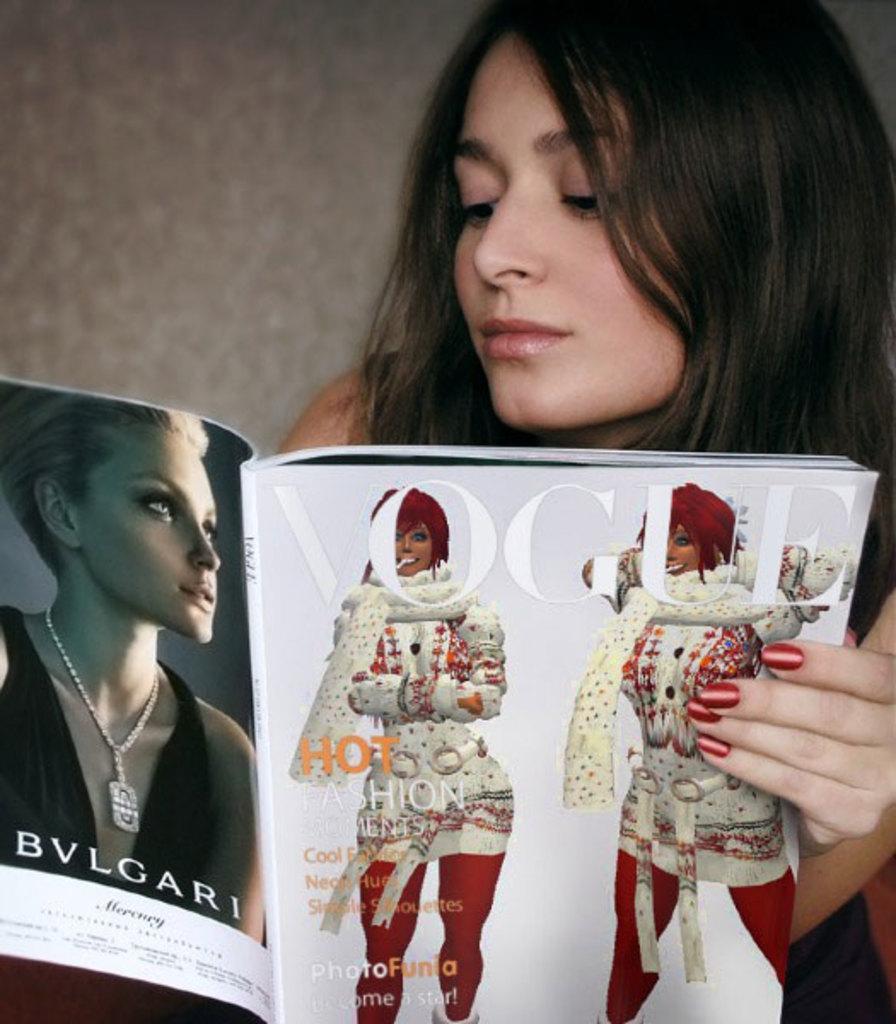How would you summarize this image in a sentence or two? In the image there is a woman looking at a magazine, she have red paint on her nails and behind her there is wall. 